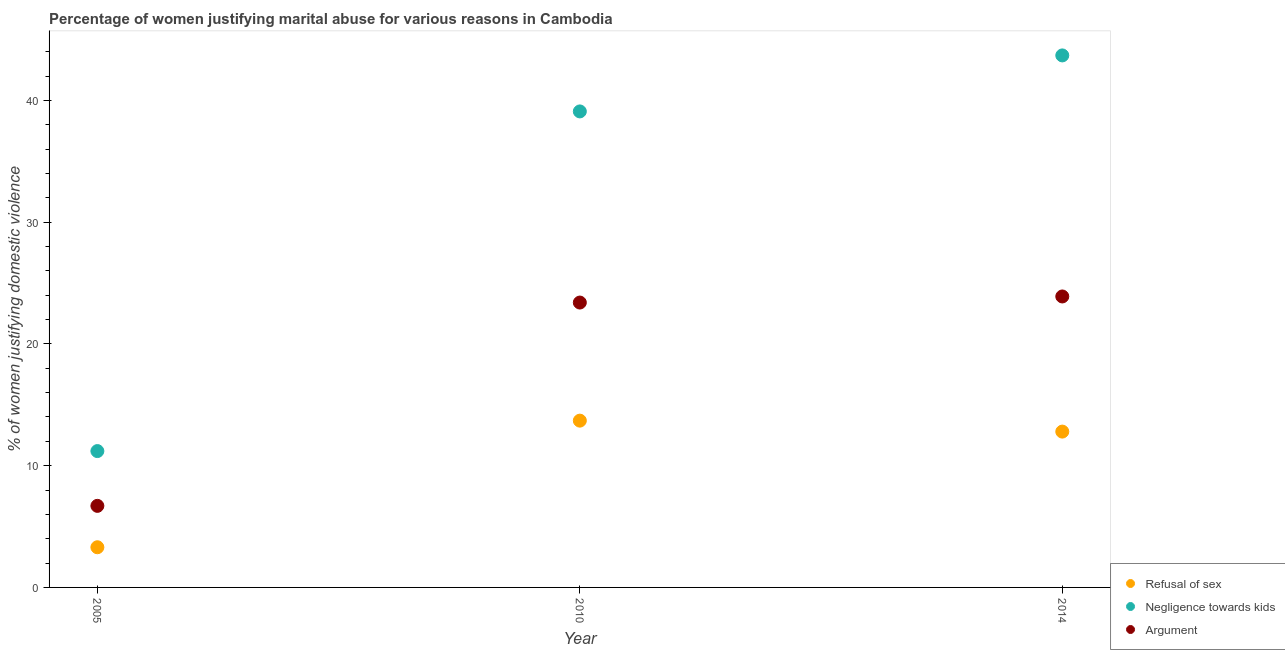How many different coloured dotlines are there?
Your answer should be very brief. 3. Is the number of dotlines equal to the number of legend labels?
Offer a terse response. Yes. What is the percentage of women justifying domestic violence due to arguments in 2010?
Your answer should be very brief. 23.4. Across all years, what is the maximum percentage of women justifying domestic violence due to arguments?
Make the answer very short. 23.9. Across all years, what is the minimum percentage of women justifying domestic violence due to negligence towards kids?
Make the answer very short. 11.2. In which year was the percentage of women justifying domestic violence due to refusal of sex maximum?
Provide a short and direct response. 2010. What is the total percentage of women justifying domestic violence due to negligence towards kids in the graph?
Provide a succinct answer. 94. What is the difference between the percentage of women justifying domestic violence due to negligence towards kids in 2010 and that in 2014?
Ensure brevity in your answer.  -4.6. What is the difference between the percentage of women justifying domestic violence due to arguments in 2014 and the percentage of women justifying domestic violence due to refusal of sex in 2005?
Offer a very short reply. 20.6. In the year 2005, what is the difference between the percentage of women justifying domestic violence due to arguments and percentage of women justifying domestic violence due to refusal of sex?
Your response must be concise. 3.4. What is the ratio of the percentage of women justifying domestic violence due to arguments in 2010 to that in 2014?
Offer a very short reply. 0.98. What is the difference between the highest and the second highest percentage of women justifying domestic violence due to negligence towards kids?
Provide a short and direct response. 4.6. What is the difference between the highest and the lowest percentage of women justifying domestic violence due to negligence towards kids?
Offer a very short reply. 32.5. Is it the case that in every year, the sum of the percentage of women justifying domestic violence due to refusal of sex and percentage of women justifying domestic violence due to negligence towards kids is greater than the percentage of women justifying domestic violence due to arguments?
Offer a very short reply. Yes. How many dotlines are there?
Give a very brief answer. 3. Does the graph contain any zero values?
Give a very brief answer. No. Does the graph contain grids?
Give a very brief answer. No. How many legend labels are there?
Your answer should be very brief. 3. What is the title of the graph?
Provide a succinct answer. Percentage of women justifying marital abuse for various reasons in Cambodia. What is the label or title of the X-axis?
Provide a succinct answer. Year. What is the label or title of the Y-axis?
Provide a short and direct response. % of women justifying domestic violence. What is the % of women justifying domestic violence of Argument in 2005?
Offer a terse response. 6.7. What is the % of women justifying domestic violence in Negligence towards kids in 2010?
Make the answer very short. 39.1. What is the % of women justifying domestic violence in Argument in 2010?
Ensure brevity in your answer.  23.4. What is the % of women justifying domestic violence in Refusal of sex in 2014?
Make the answer very short. 12.8. What is the % of women justifying domestic violence of Negligence towards kids in 2014?
Give a very brief answer. 43.7. What is the % of women justifying domestic violence in Argument in 2014?
Keep it short and to the point. 23.9. Across all years, what is the maximum % of women justifying domestic violence in Refusal of sex?
Your response must be concise. 13.7. Across all years, what is the maximum % of women justifying domestic violence of Negligence towards kids?
Make the answer very short. 43.7. Across all years, what is the maximum % of women justifying domestic violence of Argument?
Keep it short and to the point. 23.9. Across all years, what is the minimum % of women justifying domestic violence of Refusal of sex?
Provide a succinct answer. 3.3. Across all years, what is the minimum % of women justifying domestic violence of Negligence towards kids?
Offer a very short reply. 11.2. Across all years, what is the minimum % of women justifying domestic violence in Argument?
Your response must be concise. 6.7. What is the total % of women justifying domestic violence of Refusal of sex in the graph?
Ensure brevity in your answer.  29.8. What is the total % of women justifying domestic violence in Negligence towards kids in the graph?
Your response must be concise. 94. What is the total % of women justifying domestic violence of Argument in the graph?
Ensure brevity in your answer.  54. What is the difference between the % of women justifying domestic violence in Negligence towards kids in 2005 and that in 2010?
Give a very brief answer. -27.9. What is the difference between the % of women justifying domestic violence in Argument in 2005 and that in 2010?
Your answer should be compact. -16.7. What is the difference between the % of women justifying domestic violence of Negligence towards kids in 2005 and that in 2014?
Your answer should be compact. -32.5. What is the difference between the % of women justifying domestic violence of Argument in 2005 and that in 2014?
Provide a short and direct response. -17.2. What is the difference between the % of women justifying domestic violence of Argument in 2010 and that in 2014?
Ensure brevity in your answer.  -0.5. What is the difference between the % of women justifying domestic violence of Refusal of sex in 2005 and the % of women justifying domestic violence of Negligence towards kids in 2010?
Make the answer very short. -35.8. What is the difference between the % of women justifying domestic violence in Refusal of sex in 2005 and the % of women justifying domestic violence in Argument in 2010?
Give a very brief answer. -20.1. What is the difference between the % of women justifying domestic violence of Negligence towards kids in 2005 and the % of women justifying domestic violence of Argument in 2010?
Offer a very short reply. -12.2. What is the difference between the % of women justifying domestic violence in Refusal of sex in 2005 and the % of women justifying domestic violence in Negligence towards kids in 2014?
Make the answer very short. -40.4. What is the difference between the % of women justifying domestic violence of Refusal of sex in 2005 and the % of women justifying domestic violence of Argument in 2014?
Your response must be concise. -20.6. What is the difference between the % of women justifying domestic violence in Negligence towards kids in 2005 and the % of women justifying domestic violence in Argument in 2014?
Give a very brief answer. -12.7. What is the average % of women justifying domestic violence in Refusal of sex per year?
Provide a succinct answer. 9.93. What is the average % of women justifying domestic violence in Negligence towards kids per year?
Your answer should be very brief. 31.33. What is the average % of women justifying domestic violence of Argument per year?
Your answer should be very brief. 18. In the year 2005, what is the difference between the % of women justifying domestic violence of Refusal of sex and % of women justifying domestic violence of Negligence towards kids?
Provide a succinct answer. -7.9. In the year 2010, what is the difference between the % of women justifying domestic violence of Refusal of sex and % of women justifying domestic violence of Negligence towards kids?
Offer a very short reply. -25.4. In the year 2014, what is the difference between the % of women justifying domestic violence in Refusal of sex and % of women justifying domestic violence in Negligence towards kids?
Make the answer very short. -30.9. In the year 2014, what is the difference between the % of women justifying domestic violence of Negligence towards kids and % of women justifying domestic violence of Argument?
Provide a short and direct response. 19.8. What is the ratio of the % of women justifying domestic violence in Refusal of sex in 2005 to that in 2010?
Provide a short and direct response. 0.24. What is the ratio of the % of women justifying domestic violence in Negligence towards kids in 2005 to that in 2010?
Your answer should be very brief. 0.29. What is the ratio of the % of women justifying domestic violence of Argument in 2005 to that in 2010?
Make the answer very short. 0.29. What is the ratio of the % of women justifying domestic violence in Refusal of sex in 2005 to that in 2014?
Your response must be concise. 0.26. What is the ratio of the % of women justifying domestic violence of Negligence towards kids in 2005 to that in 2014?
Provide a short and direct response. 0.26. What is the ratio of the % of women justifying domestic violence in Argument in 2005 to that in 2014?
Make the answer very short. 0.28. What is the ratio of the % of women justifying domestic violence in Refusal of sex in 2010 to that in 2014?
Give a very brief answer. 1.07. What is the ratio of the % of women justifying domestic violence of Negligence towards kids in 2010 to that in 2014?
Offer a very short reply. 0.89. What is the ratio of the % of women justifying domestic violence of Argument in 2010 to that in 2014?
Keep it short and to the point. 0.98. What is the difference between the highest and the second highest % of women justifying domestic violence of Argument?
Your answer should be very brief. 0.5. What is the difference between the highest and the lowest % of women justifying domestic violence in Negligence towards kids?
Your answer should be compact. 32.5. What is the difference between the highest and the lowest % of women justifying domestic violence in Argument?
Make the answer very short. 17.2. 